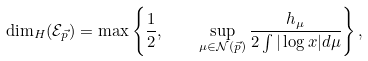<formula> <loc_0><loc_0><loc_500><loc_500>\dim _ { H } ( \mathcal { E } _ { \vec { p } } ) = \max \left \{ \frac { 1 } { 2 } , \quad \sup _ { \mu \in { \mathcal { N } } ( \vec { p } ) } \frac { h _ { \mu } } { 2 \int | \log x | d \mu } \right \} ,</formula> 